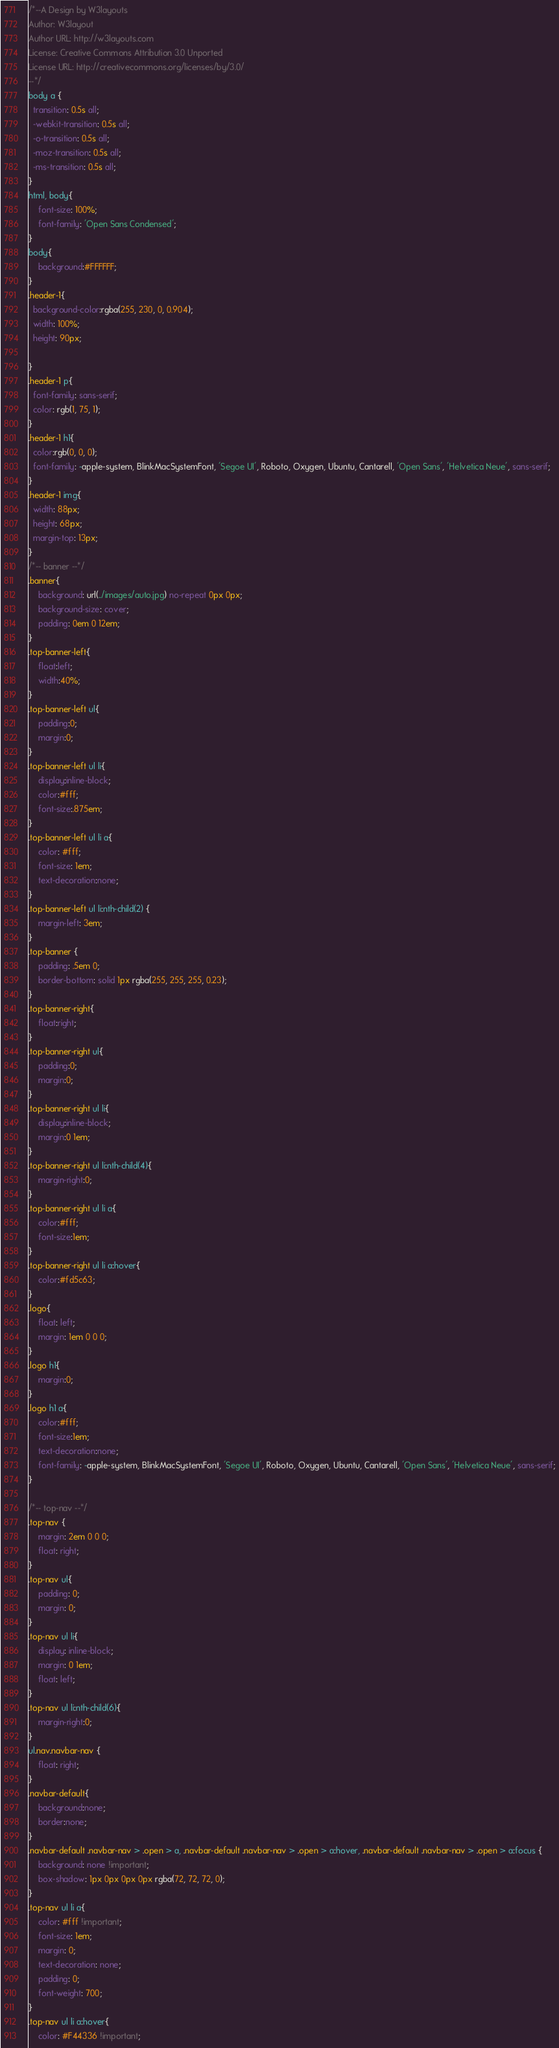Convert code to text. <code><loc_0><loc_0><loc_500><loc_500><_CSS_>/*--A Design by W3layouts 
Author: W3layout
Author URL: http://w3layouts.com
License: Creative Commons Attribution 3.0 Unported
License URL: http://creativecommons.org/licenses/by/3.0/
--*/
body a {
  transition: 0.5s all;
  -webkit-transition: 0.5s all;
  -o-transition: 0.5s all;
  -moz-transition: 0.5s all;
  -ms-transition: 0.5s all;
}
html, body{
    font-size: 100%;
	font-family: 'Open Sans Condensed';
}
body{
	background:#FFFFFF;
}
.header-1{
  background-color:rgba(255, 230, 0, 0.904);
  width: 100%;
  height: 90px;
  
}
.header-1 p{
  font-family: sans-serif;
  color: rgb(1, 75, 1);
}
.header-1 h1{
  color:rgb(0, 0, 0);
  font-family: -apple-system, BlinkMacSystemFont, 'Segoe UI', Roboto, Oxygen, Ubuntu, Cantarell, 'Open Sans', 'Helvetica Neue', sans-serif;
}
.header-1 img{
  width: 88px;
  height: 68px;
  margin-top: 13px;
}
/*-- banner --*/
.banner{
    background: url(../images/auto.jpg) no-repeat 0px 0px;
    background-size: cover;
    padding: 0em 0 12em;
}
.top-banner-left{
	float:left;
	width:40%;
}
.top-banner-left ul{
	padding:0;
	margin:0;
}
.top-banner-left ul li{
	display:inline-block;
	color:#fff;
	font-size:.875em;
}
.top-banner-left ul li a{
    color: #fff;
    font-size: 1em;
	text-decoration:none;
}
.top-banner-left ul li:nth-child(2) {
    margin-left: 3em;
}
.top-banner {
    padding: .5em 0;
    border-bottom: solid 1px rgba(255, 255, 255, 0.23);
}
.top-banner-right{
	float:right;
}
.top-banner-right ul{
	padding:0;
	margin:0;
}
.top-banner-right ul li{
	display:inline-block;
	margin:0 1em;
}
.top-banner-right ul li:nth-child(4){
	margin-right:0;
}
.top-banner-right ul li a{
	color:#fff;
	font-size:1em;
}
.top-banner-right ul li a:hover{
	color:#fd5c63;
}
.logo{
    float: left;
    margin: 1em 0 0 0;
}
.logo h1{
	margin:0;
}
.logo h1 a{
	color:#fff;
	font-size:1em;
	text-decoration:none;
	font-family: -apple-system, BlinkMacSystemFont, 'Segoe UI', Roboto, Oxygen, Ubuntu, Cantarell, 'Open Sans', 'Helvetica Neue', sans-serif;
}
 
/*-- top-nav --*/
.top-nav {
    margin: 2em 0 0 0;
	float: right;
}
.top-nav ul{
    padding: 0;
    margin: 0;
}
.top-nav ul li{
    display: inline-block;
    margin: 0 1em;
    float: left;
}
.top-nav ul li:nth-child(6){
	margin-right:0;
}
ul.nav.navbar-nav {
    float: right;
}
.navbar-default{
	background:none;
	border:none;
}
.navbar-default .navbar-nav > .open > a, .navbar-default .navbar-nav > .open > a:hover, .navbar-default .navbar-nav > .open > a:focus {
    background: none !important;
    box-shadow: 1px 0px 0px 0px rgba(72, 72, 72, 0);
}
.top-nav ul li a{
    color: #fff !important;
    font-size: 1em;
    margin: 0;
    text-decoration: none;
    padding: 0;
    font-weight: 700;
}
.top-nav ul li a:hover{
    color: #F44336 !important;</code> 